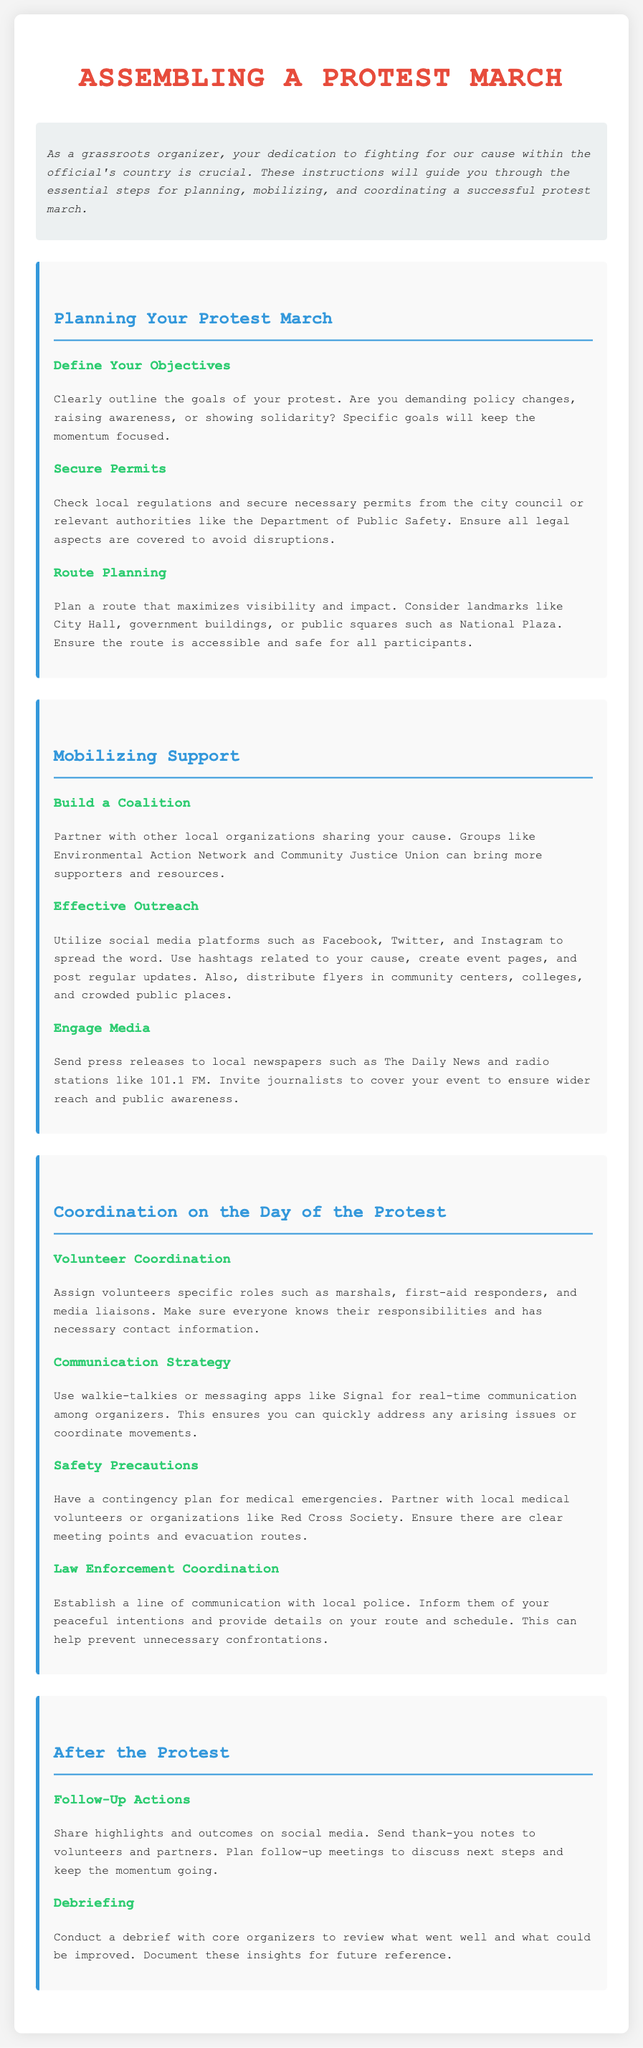What are the goals of your protest? The goals of your protest can include demands for policy changes, raising awareness, or showing solidarity.
Answer: Specific goals What should you check to avoid disruptions? Checking local regulations and securing necessary permits is essential to avoid disruptions.
Answer: Local regulations Where should the protest route maximize visibility? The protest route should maximize visibility near landmarks such as City Hall, government buildings, or public squares.
Answer: Landmarks Which organizations can help build a coalition? Partner with organizations such as Environmental Action Network and Community Justice Union to build a coalition.
Answer: Environmental Action Network, Community Justice Union What method should be used for real-time communication? Walkie-talkies or messaging apps like Signal should be used for real-time communication among organizers.
Answer: Walkie-talkies, Signal What partnership is crucial for safety precautions? Partnering with local medical volunteers or organizations like Red Cross Society is crucial for safety precautions.
Answer: Red Cross Society What actions should be taken after the protest? After the protest, share highlights on social media and send thank-you notes to volunteers and partners.
Answer: Share highlights, send thank-you notes What should be included in the debriefing? The debriefing should include a review of what went well and what could be improved.
Answer: Review successes and improvements 